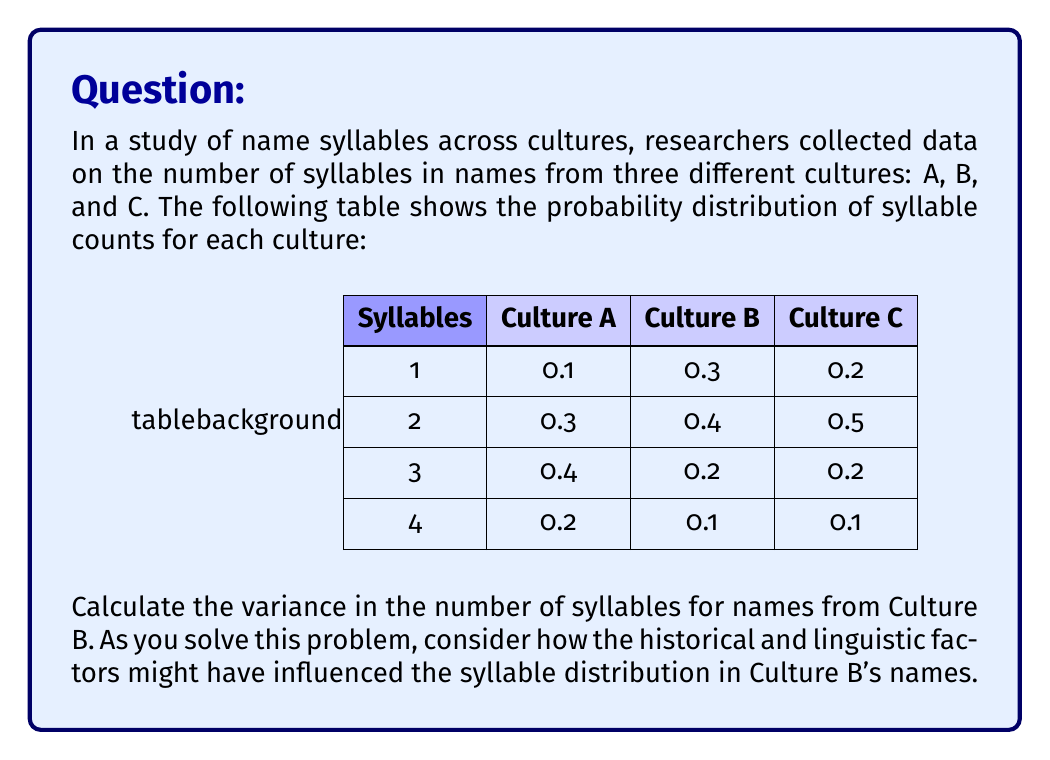Teach me how to tackle this problem. To calculate the variance, we'll follow these steps:

1. Calculate the expected value (mean) of the number of syllables:
   $E(X) = \sum_{i=1}^{n} x_i \cdot p(x_i)$
   
   $E(X) = 1 \cdot 0.3 + 2 \cdot 0.4 + 3 \cdot 0.2 + 4 \cdot 0.1 = 2.1$

2. Calculate $E(X^2)$:
   $E(X^2) = \sum_{i=1}^{n} x_i^2 \cdot p(x_i)$
   
   $E(X^2) = 1^2 \cdot 0.3 + 2^2 \cdot 0.4 + 3^2 \cdot 0.2 + 4^2 \cdot 0.1 = 5.1$

3. Use the variance formula:
   $Var(X) = E(X^2) - [E(X)]^2$
   
   $Var(X) = 5.1 - (2.1)^2 = 5.1 - 4.41 = 0.69$

Historical and linguistic considerations:
The distribution shows that Culture B has a preference for names with 1 or 2 syllables (70% combined). This could indicate a linguistic tradition favoring shorter names, possibly influenced by historical factors such as naming conventions, phonetic structure of the language, or cultural values emphasizing simplicity or efficiency in communication.
Answer: $Var(X) = 0.69$ 